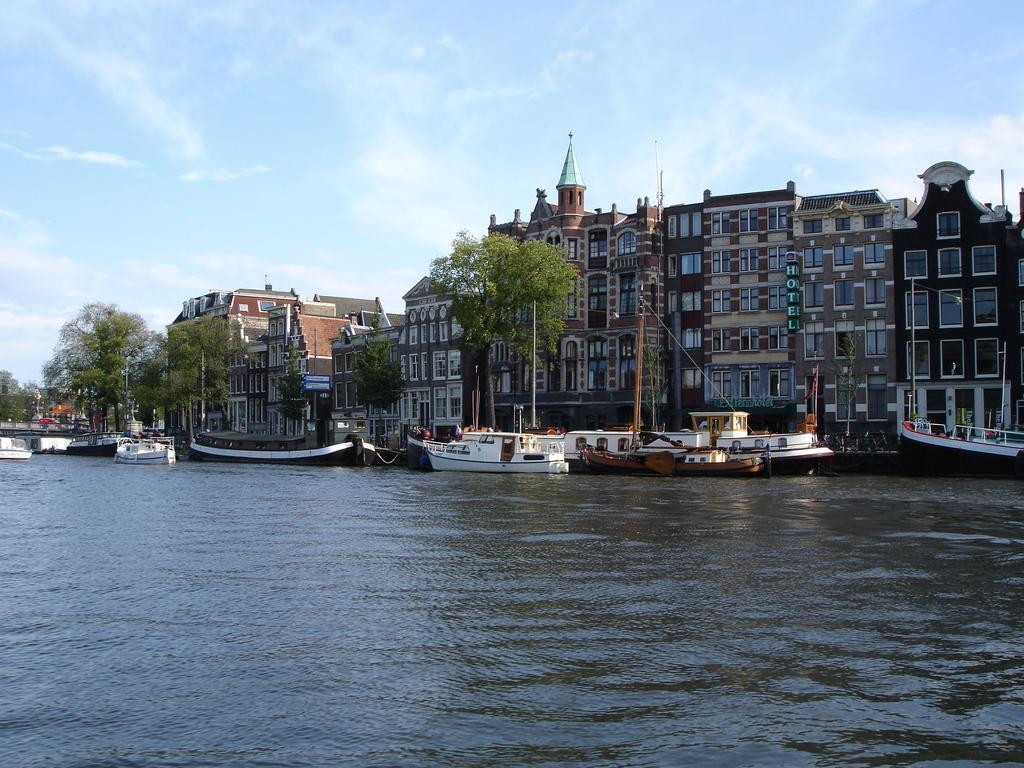How would you summarize this image in a sentence or two? In this image there are boats on a river, in the background there are trees, buildings and the sky. 